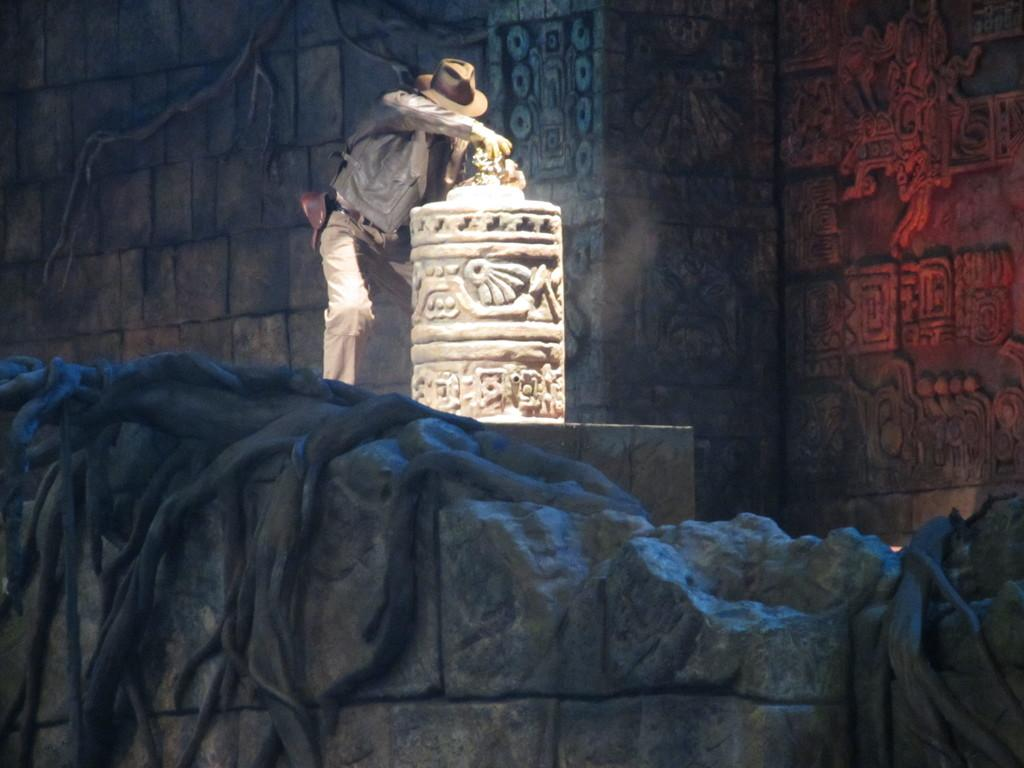What is the main subject of the image? There is a person standing in the image. What can be seen in the background of the image? There is an object that looks like a sculpture and a wall visible in the background of the image. What type of shoe can be seen bursting in the image? There is no shoe present in the image, let alone a bursting one. 